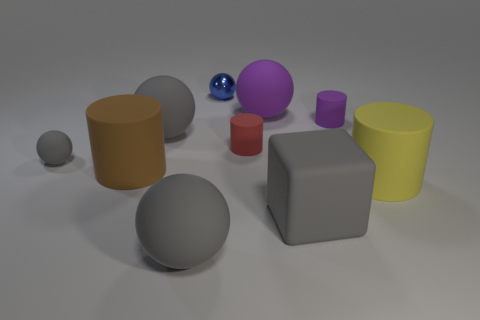Subtract all blue cylinders. How many gray spheres are left? 3 Subtract all tiny gray rubber balls. How many balls are left? 4 Subtract all purple spheres. How many spheres are left? 4 Subtract all brown spheres. Subtract all purple cylinders. How many spheres are left? 5 Subtract all blocks. How many objects are left? 9 Subtract all gray balls. Subtract all red matte things. How many objects are left? 6 Add 8 large gray matte blocks. How many large gray matte blocks are left? 9 Add 4 large gray blocks. How many large gray blocks exist? 5 Subtract 0 green cubes. How many objects are left? 10 